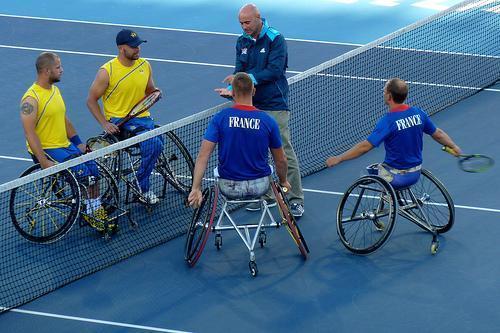How many people are in wheelchairs?
Give a very brief answer. 4. How many people have "FRANCE" written on the their shirt?
Give a very brief answer. 2. How many people are in this photo?
Give a very brief answer. 5. 